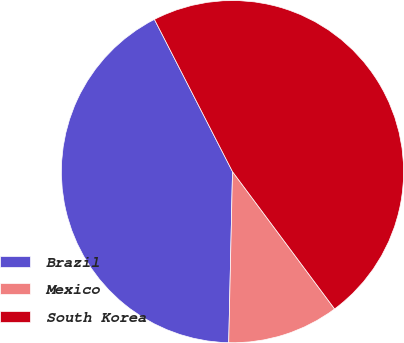Convert chart. <chart><loc_0><loc_0><loc_500><loc_500><pie_chart><fcel>Brazil<fcel>Mexico<fcel>South Korea<nl><fcel>42.11%<fcel>10.53%<fcel>47.37%<nl></chart> 